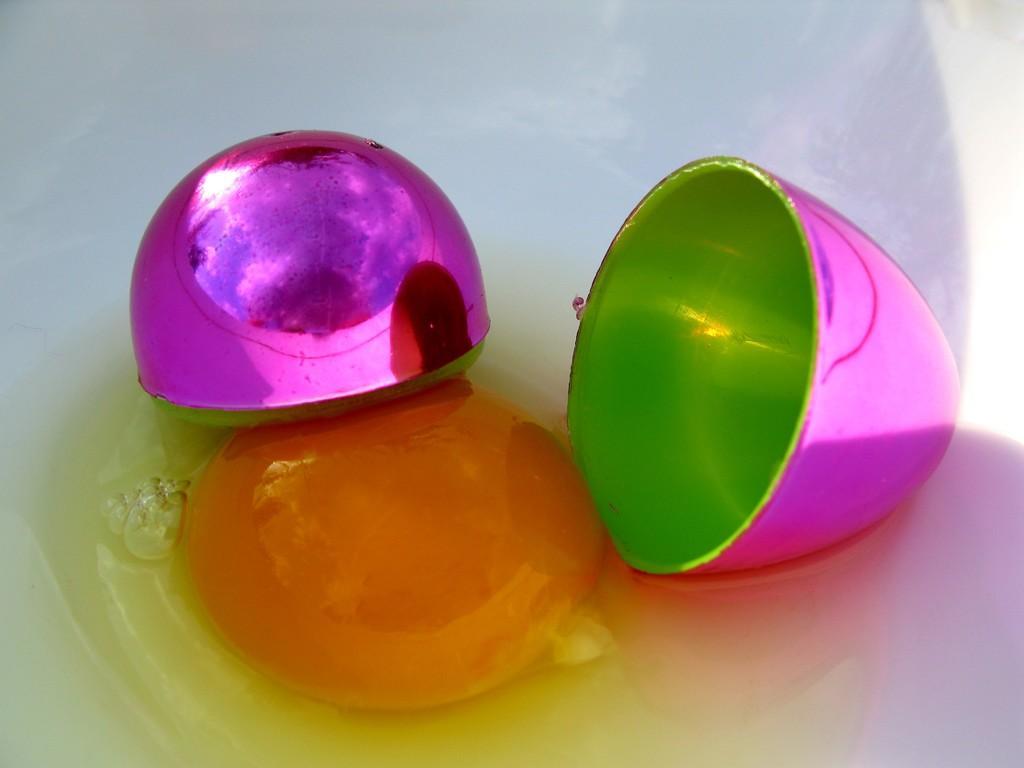Describe this image in one or two sentences. In this image I can see a white colored bowel and in the bowl I can see the egg white and yolk and I can see a plastic egg which is pink and green in color. 